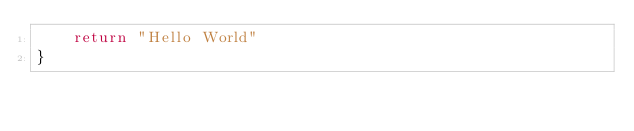<code> <loc_0><loc_0><loc_500><loc_500><_Go_>	return "Hello World"
}
</code> 